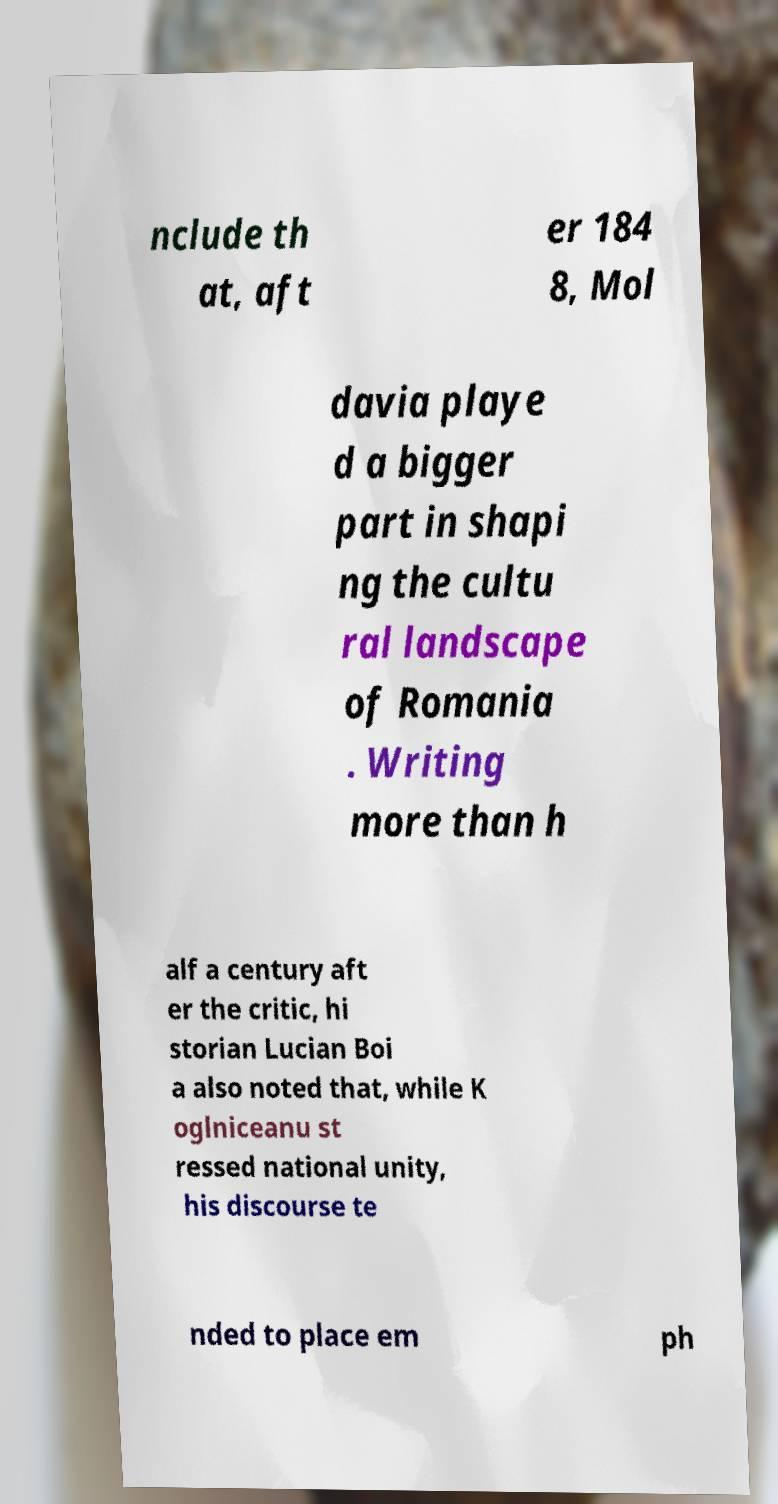Can you read and provide the text displayed in the image?This photo seems to have some interesting text. Can you extract and type it out for me? nclude th at, aft er 184 8, Mol davia playe d a bigger part in shapi ng the cultu ral landscape of Romania . Writing more than h alf a century aft er the critic, hi storian Lucian Boi a also noted that, while K oglniceanu st ressed national unity, his discourse te nded to place em ph 